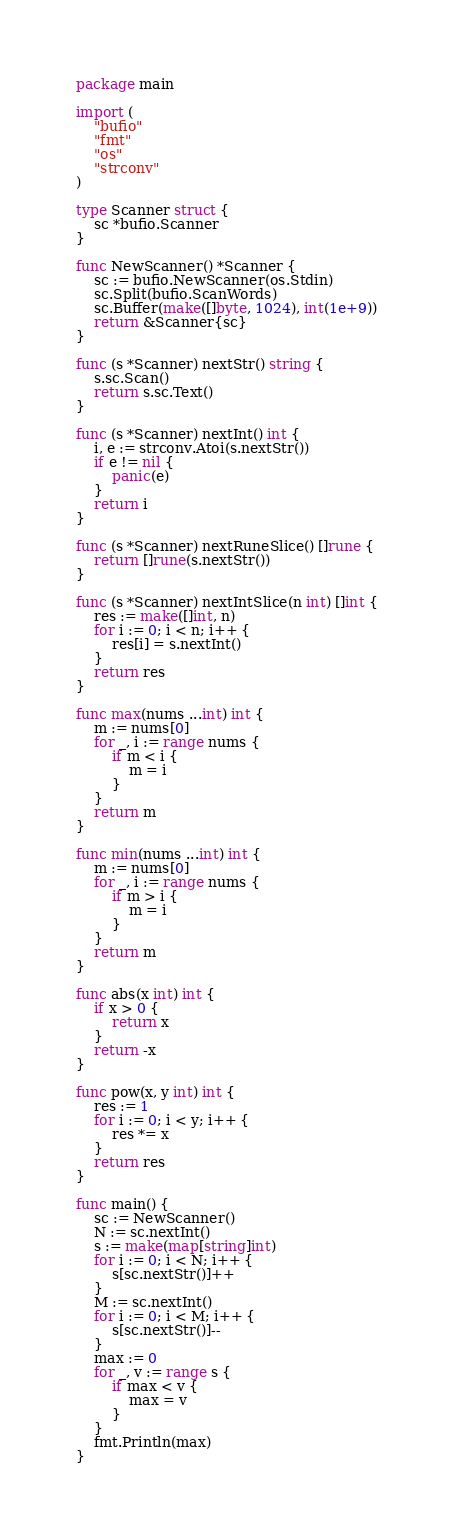Convert code to text. <code><loc_0><loc_0><loc_500><loc_500><_Go_>package main

import (
	"bufio"
	"fmt"
	"os"
	"strconv"
)

type Scanner struct {
	sc *bufio.Scanner
}

func NewScanner() *Scanner {
	sc := bufio.NewScanner(os.Stdin)
	sc.Split(bufio.ScanWords)
	sc.Buffer(make([]byte, 1024), int(1e+9))
	return &Scanner{sc}
}

func (s *Scanner) nextStr() string {
	s.sc.Scan()
	return s.sc.Text()
}

func (s *Scanner) nextInt() int {
	i, e := strconv.Atoi(s.nextStr())
	if e != nil {
		panic(e)
	}
	return i
}

func (s *Scanner) nextRuneSlice() []rune {
	return []rune(s.nextStr())
}

func (s *Scanner) nextIntSlice(n int) []int {
	res := make([]int, n)
	for i := 0; i < n; i++ {
		res[i] = s.nextInt()
	}
	return res
}

func max(nums ...int) int {
	m := nums[0]
	for _, i := range nums {
		if m < i {
			m = i
		}
	}
	return m
}

func min(nums ...int) int {
	m := nums[0]
	for _, i := range nums {
		if m > i {
			m = i
		}
	}
	return m
}

func abs(x int) int {
	if x > 0 {
		return x
	}
	return -x
}

func pow(x, y int) int {
	res := 1
	for i := 0; i < y; i++ {
		res *= x
	}
	return res
}

func main() {
	sc := NewScanner()
	N := sc.nextInt()
	s := make(map[string]int)
	for i := 0; i < N; i++ {
		s[sc.nextStr()]++
	}
	M := sc.nextInt()
	for i := 0; i < M; i++ {
		s[sc.nextStr()]--
	}
	max := 0
	for _, v := range s {
		if max < v {
			max = v
		}
	}
	fmt.Println(max)
}
</code> 